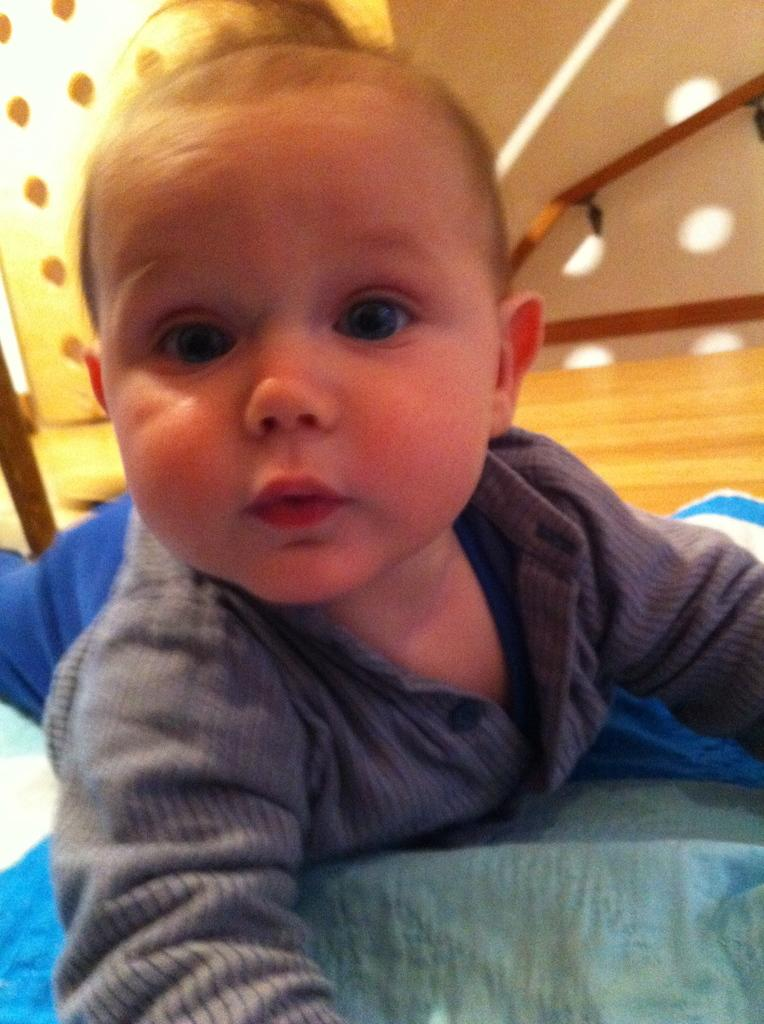What is the main subject in the image? There is a kid lying on the floor in the center of the image. What is at the bottom of the image? There is a cloth at the bottom of the image. What is visible at the top of the image? There is a wall and an object visible at the top of the image. What type of skirt is the kid wearing in the image? The image does not show the kid wearing a skirt. 